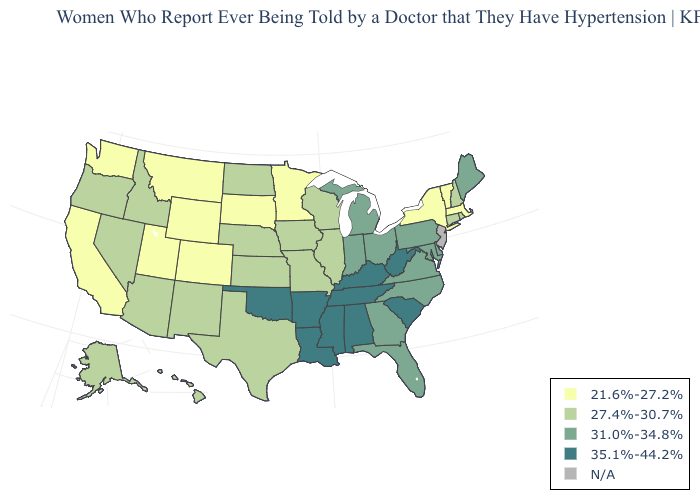Name the states that have a value in the range 27.4%-30.7%?
Quick response, please. Alaska, Arizona, Connecticut, Hawaii, Idaho, Illinois, Iowa, Kansas, Missouri, Nebraska, Nevada, New Hampshire, New Mexico, North Dakota, Oregon, Rhode Island, Texas, Wisconsin. How many symbols are there in the legend?
Write a very short answer. 5. Among the states that border Iowa , which have the highest value?
Answer briefly. Illinois, Missouri, Nebraska, Wisconsin. Name the states that have a value in the range 35.1%-44.2%?
Short answer required. Alabama, Arkansas, Kentucky, Louisiana, Mississippi, Oklahoma, South Carolina, Tennessee, West Virginia. What is the lowest value in the USA?
Answer briefly. 21.6%-27.2%. What is the value of Virginia?
Answer briefly. 31.0%-34.8%. What is the value of Connecticut?
Be succinct. 27.4%-30.7%. Among the states that border Tennessee , does Kentucky have the highest value?
Keep it brief. Yes. How many symbols are there in the legend?
Short answer required. 5. What is the value of North Carolina?
Keep it brief. 31.0%-34.8%. Among the states that border Texas , does New Mexico have the highest value?
Answer briefly. No. What is the value of Kentucky?
Be succinct. 35.1%-44.2%. Name the states that have a value in the range N/A?
Write a very short answer. New Jersey. What is the value of Indiana?
Answer briefly. 31.0%-34.8%. What is the highest value in the West ?
Answer briefly. 27.4%-30.7%. 